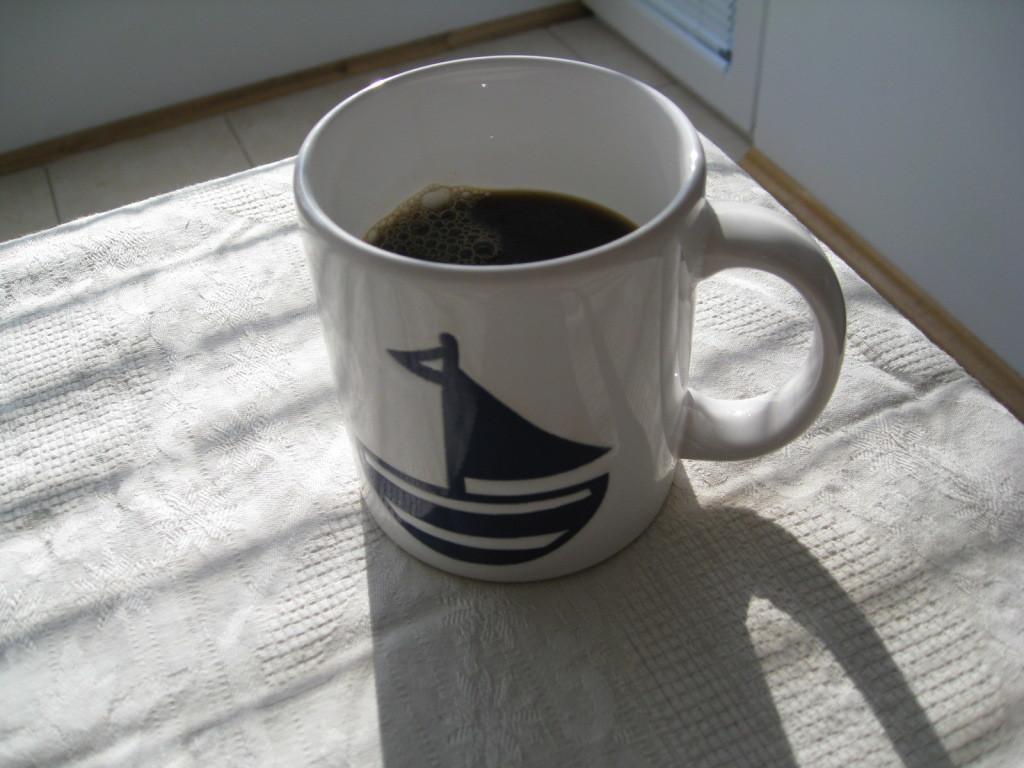In one or two sentences, can you explain what this image depicts? We can see cup with drink on cloth and we can see floor, wall and door. 